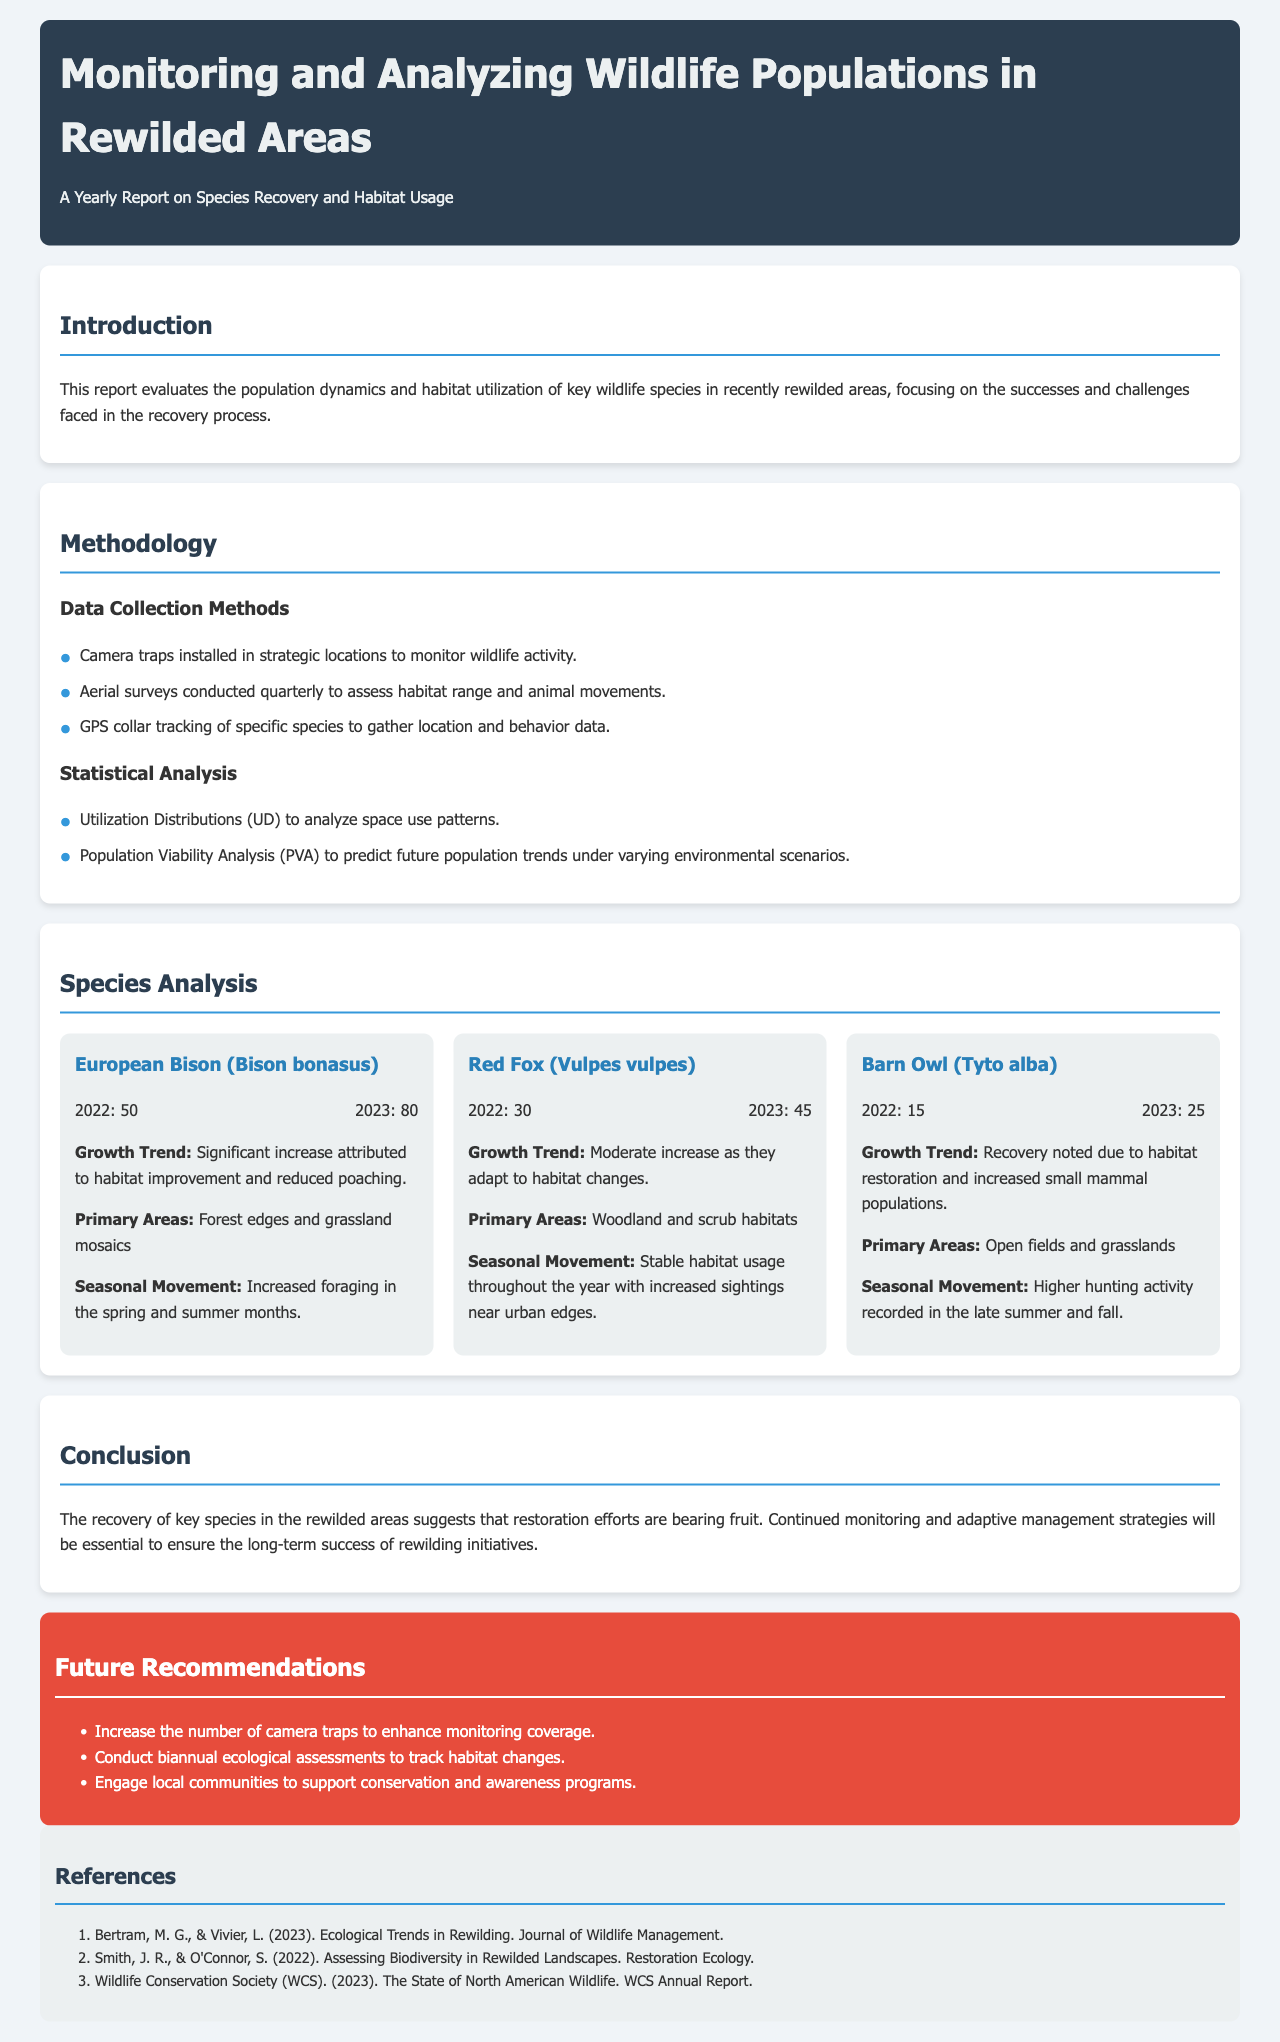What is the title of the report? The title of the report is presented in the header section of the document.
Answer: Monitoring and Analyzing Wildlife Populations in Rewilded Areas What species showed the highest population growth from 2022 to 2023? The population change information provides specific data on species growth, where the species with the most significant increase is identified.
Answer: European Bison What was the population of Barn Owls in 2022? The population of Barn Owls in 2022 is specified in the species analysis section, providing the relevant historical data.
Answer: 15 What type of surveys were conducted quarterly? The methodology section lists the data collection methods, which include specific survey types that were performed quarterly.
Answer: Aerial surveys Which species primarily occupied open fields and grasslands? The species analysis section describes habitat usage, making it clear which species is associated with specific habitats.
Answer: Barn Owl What future recommendation involves engaging local communities? The recommendations section provides specific suggestions for future actions, including community engagement.
Answer: Engage local communities What was the primary reason for the increase in the European Bison population? The growth trend section specifies the contributing factors to the population increase of the European Bison.
Answer: Habitat improvement and reduced poaching How many camera traps should be increased according to the recommendations? The recommendations section mentions the suggestion to increase the number of specific monitoring tools without stating a specific number.
Answer: Not specified What were the primary areas for Red Fox habitat usage? The species analysis outlines the habitats in which the Red Fox is predominantly found.
Answer: Woodland and scrub habitats 